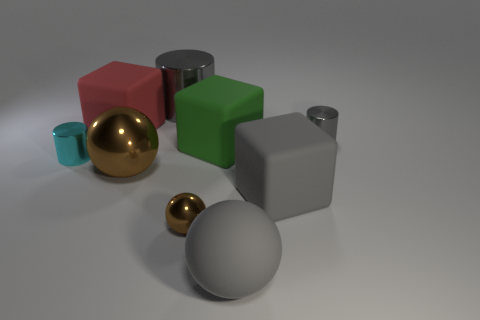What number of other objects are the same size as the cyan shiny thing?
Ensure brevity in your answer.  2. There is a gray object that is the same shape as the green thing; what material is it?
Provide a short and direct response. Rubber. What is the big block to the left of the big metal thing that is behind the big sphere left of the green matte thing made of?
Your response must be concise. Rubber. What is the size of the cyan thing that is made of the same material as the small gray cylinder?
Give a very brief answer. Small. Does the sphere that is behind the small brown shiny thing have the same color as the small sphere on the right side of the large brown metal thing?
Give a very brief answer. Yes. There is a ball that is on the right side of the small brown metal thing; what is its color?
Offer a terse response. Gray. Do the cylinder that is on the right side of the gray cube and the large gray cylinder have the same size?
Offer a terse response. No. Is the number of tiny balls less than the number of brown balls?
Give a very brief answer. Yes. There is a large metal thing that is the same color as the small ball; what shape is it?
Ensure brevity in your answer.  Sphere. What number of gray rubber objects are on the right side of the big gray shiny thing?
Offer a terse response. 2. 